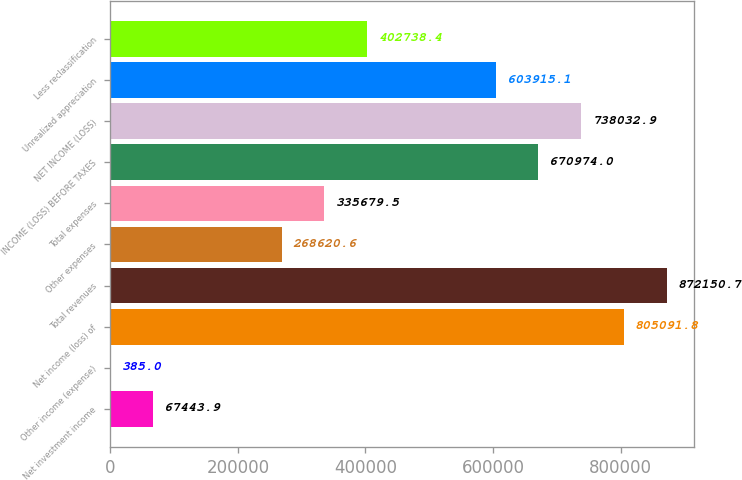Convert chart. <chart><loc_0><loc_0><loc_500><loc_500><bar_chart><fcel>Net investment income<fcel>Other income (expense)<fcel>Net income (loss) of<fcel>Total revenues<fcel>Other expenses<fcel>Total expenses<fcel>INCOME (LOSS) BEFORE TAXES<fcel>NET INCOME (LOSS)<fcel>Unrealized appreciation<fcel>Less reclassification<nl><fcel>67443.9<fcel>385<fcel>805092<fcel>872151<fcel>268621<fcel>335680<fcel>670974<fcel>738033<fcel>603915<fcel>402738<nl></chart> 